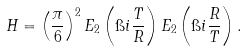Convert formula to latex. <formula><loc_0><loc_0><loc_500><loc_500>H = \left ( \frac { \pi } { 6 } \right ) ^ { 2 } E _ { 2 } \left ( \i i \frac { T } { R } \right ) E _ { 2 } \left ( \i i \frac { R } { T } \right ) .</formula> 